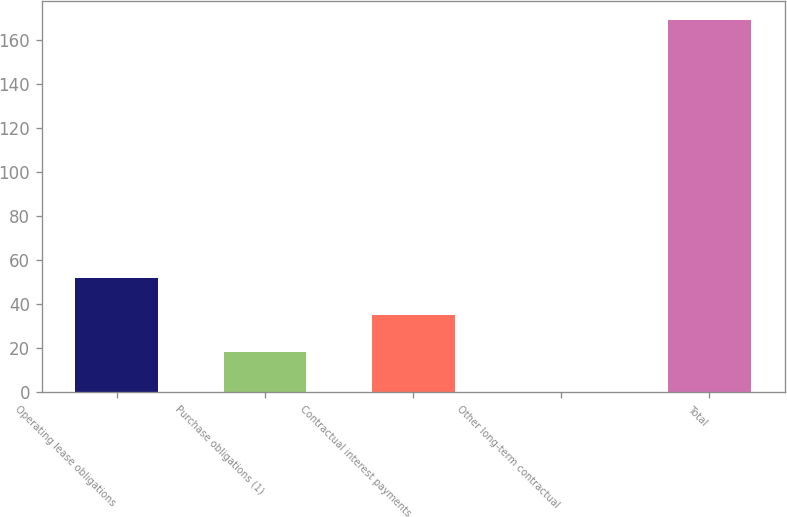Convert chart to OTSL. <chart><loc_0><loc_0><loc_500><loc_500><bar_chart><fcel>Operating lease obligations<fcel>Purchase obligations (1)<fcel>Contractual interest payments<fcel>Other long-term contractual<fcel>Total<nl><fcel>51.94<fcel>18.1<fcel>35.02<fcel>0.1<fcel>169.3<nl></chart> 